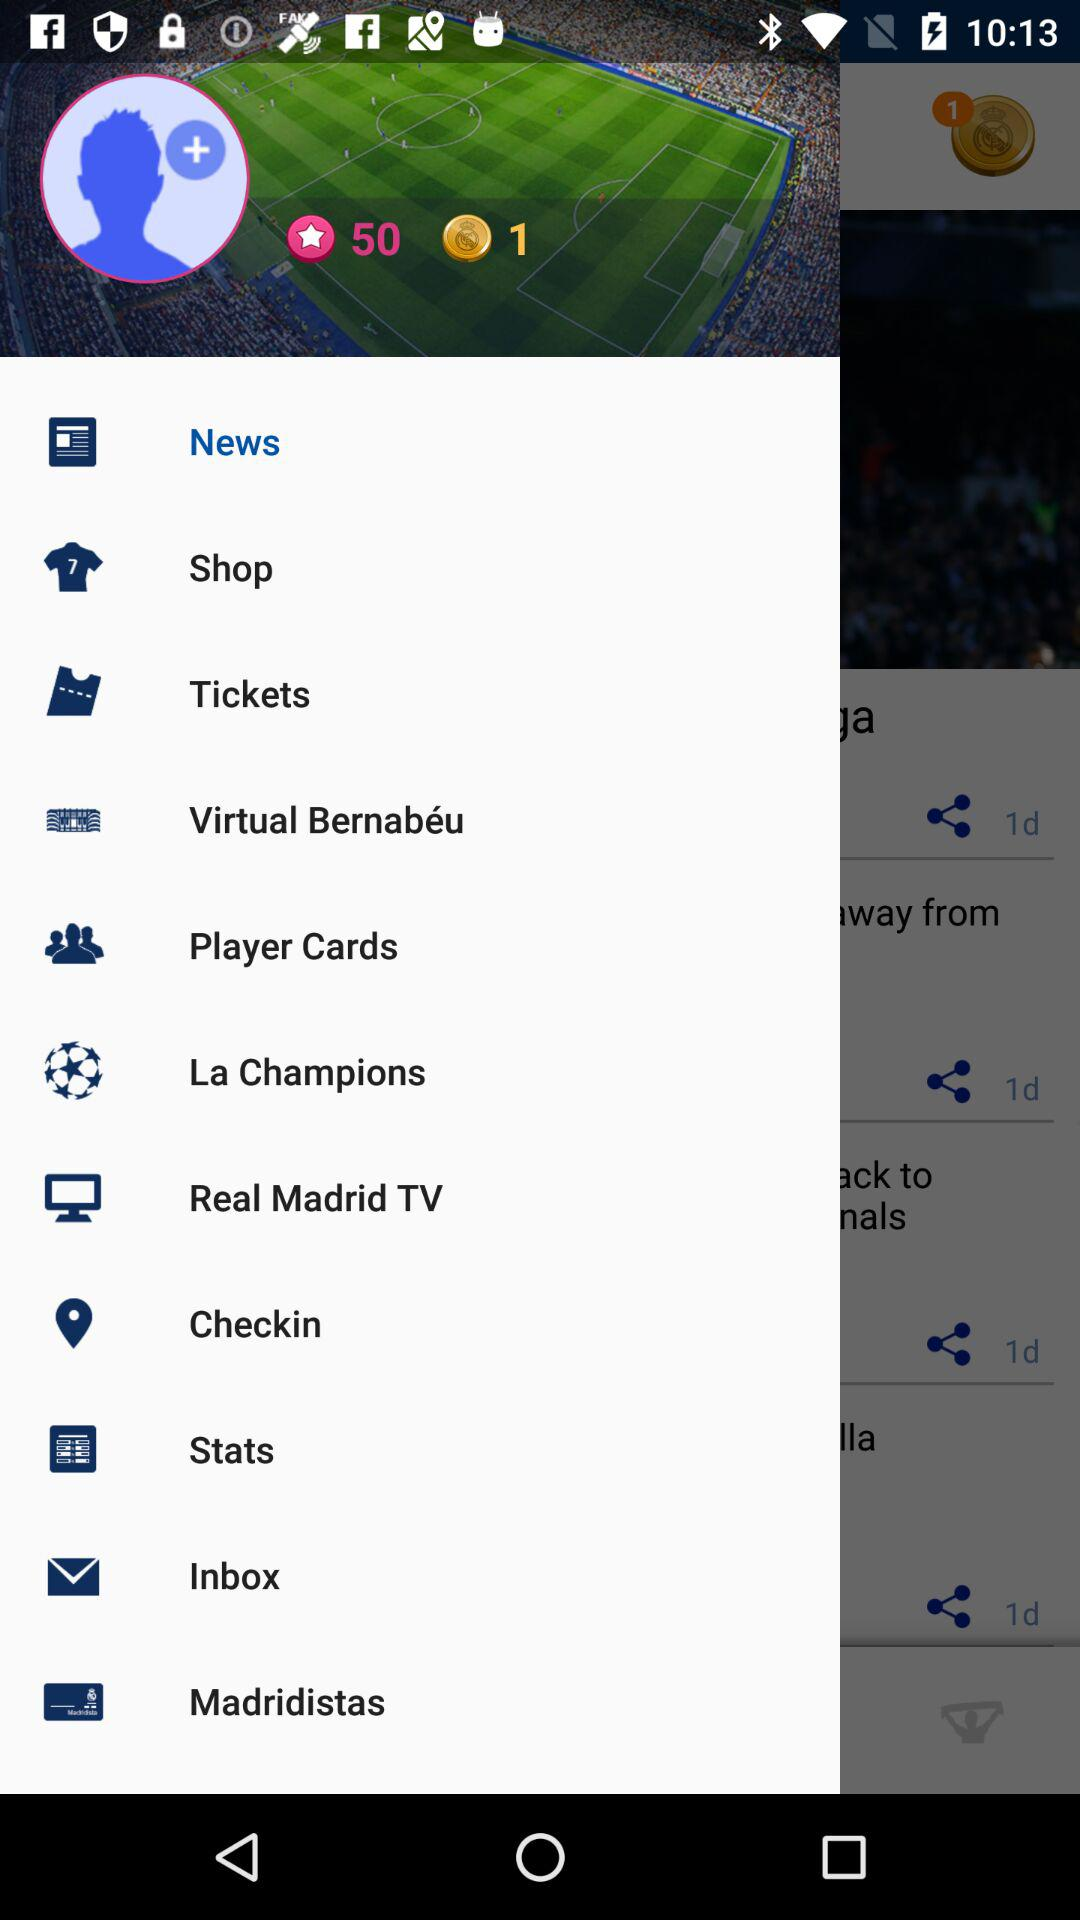What is the total number of credit points available? The total number of credit points available is 50. 